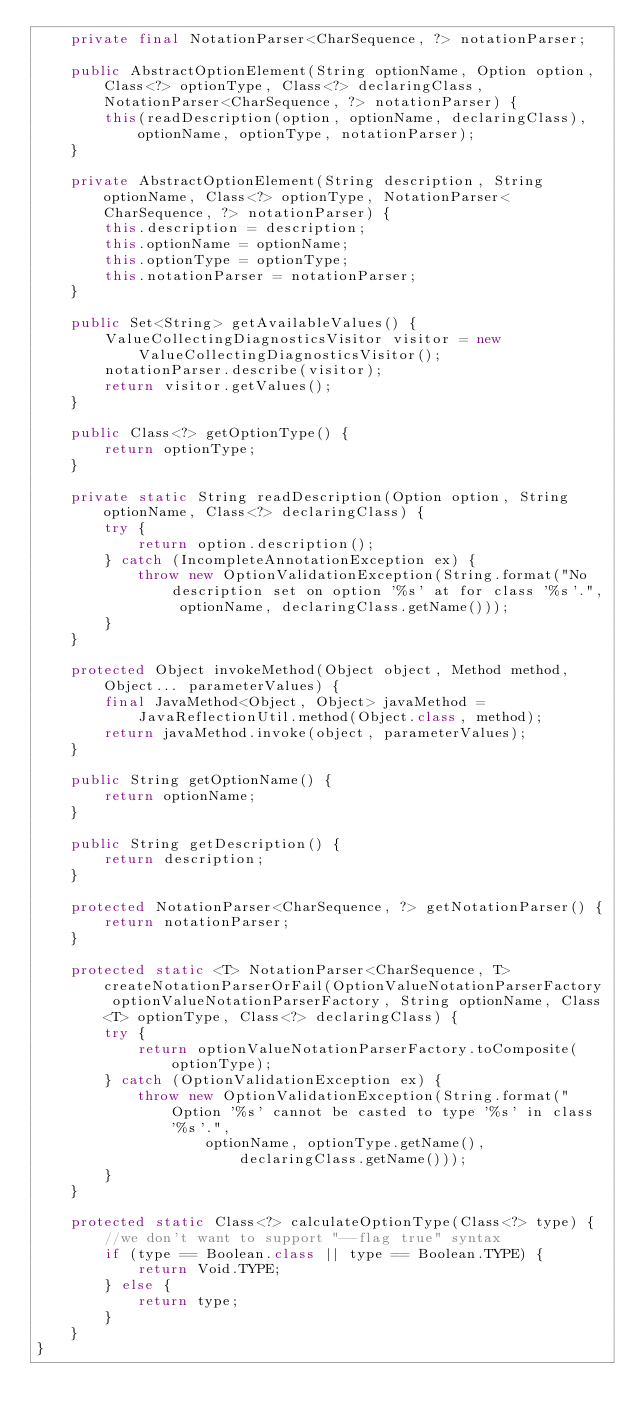<code> <loc_0><loc_0><loc_500><loc_500><_Java_>    private final NotationParser<CharSequence, ?> notationParser;

    public AbstractOptionElement(String optionName, Option option, Class<?> optionType, Class<?> declaringClass, NotationParser<CharSequence, ?> notationParser) {
        this(readDescription(option, optionName, declaringClass), optionName, optionType, notationParser);
    }

    private AbstractOptionElement(String description, String optionName, Class<?> optionType, NotationParser<CharSequence, ?> notationParser) {
        this.description = description;
        this.optionName = optionName;
        this.optionType = optionType;
        this.notationParser = notationParser;
    }

    public Set<String> getAvailableValues() {
        ValueCollectingDiagnosticsVisitor visitor = new ValueCollectingDiagnosticsVisitor();
        notationParser.describe(visitor);
        return visitor.getValues();
    }

    public Class<?> getOptionType() {
        return optionType;
    }

    private static String readDescription(Option option, String optionName, Class<?> declaringClass) {
        try {
            return option.description();
        } catch (IncompleteAnnotationException ex) {
            throw new OptionValidationException(String.format("No description set on option '%s' at for class '%s'.", optionName, declaringClass.getName()));
        }
    }

    protected Object invokeMethod(Object object, Method method, Object... parameterValues) {
        final JavaMethod<Object, Object> javaMethod = JavaReflectionUtil.method(Object.class, method);
        return javaMethod.invoke(object, parameterValues);
    }

    public String getOptionName() {
        return optionName;
    }

    public String getDescription() {
        return description;
    }

    protected NotationParser<CharSequence, ?> getNotationParser() {
        return notationParser;
    }

    protected static <T> NotationParser<CharSequence, T> createNotationParserOrFail(OptionValueNotationParserFactory optionValueNotationParserFactory, String optionName, Class<T> optionType, Class<?> declaringClass) {
        try {
            return optionValueNotationParserFactory.toComposite(optionType);
        } catch (OptionValidationException ex) {
            throw new OptionValidationException(String.format("Option '%s' cannot be casted to type '%s' in class '%s'.",
                    optionName, optionType.getName(), declaringClass.getName()));
        }
    }

    protected static Class<?> calculateOptionType(Class<?> type) {
        //we don't want to support "--flag true" syntax
        if (type == Boolean.class || type == Boolean.TYPE) {
            return Void.TYPE;
        } else {
            return type;
        }
    }
}
</code> 